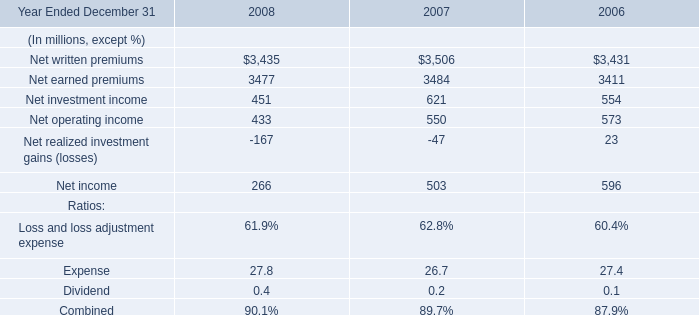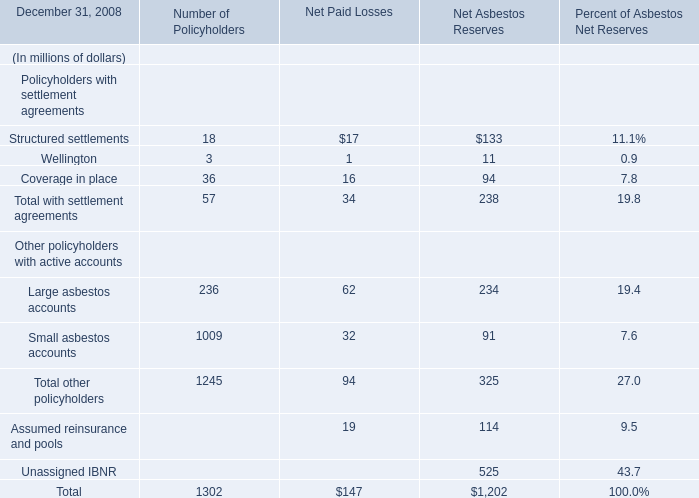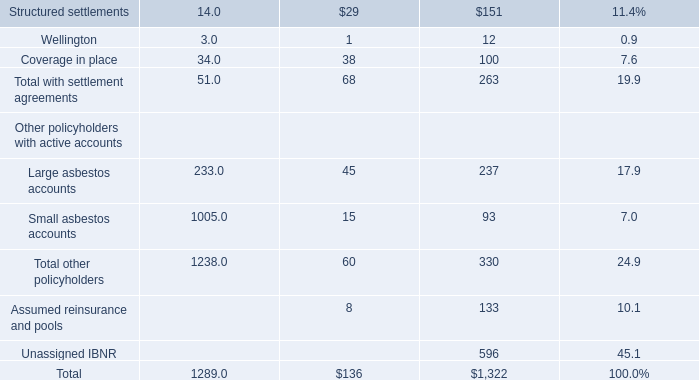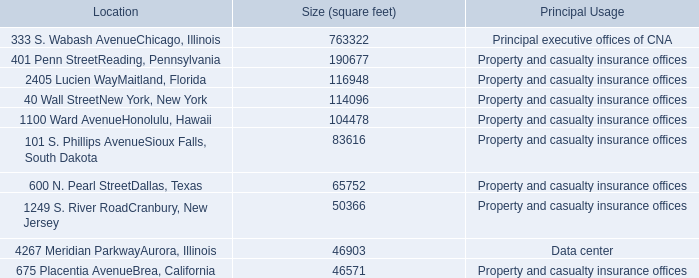What's the sum of Small asbestos accounts Other policyholders with active accounts, and Net written premiums of 2006 ? 
Computations: (1005.0 + 3431.0)
Answer: 4436.0. 